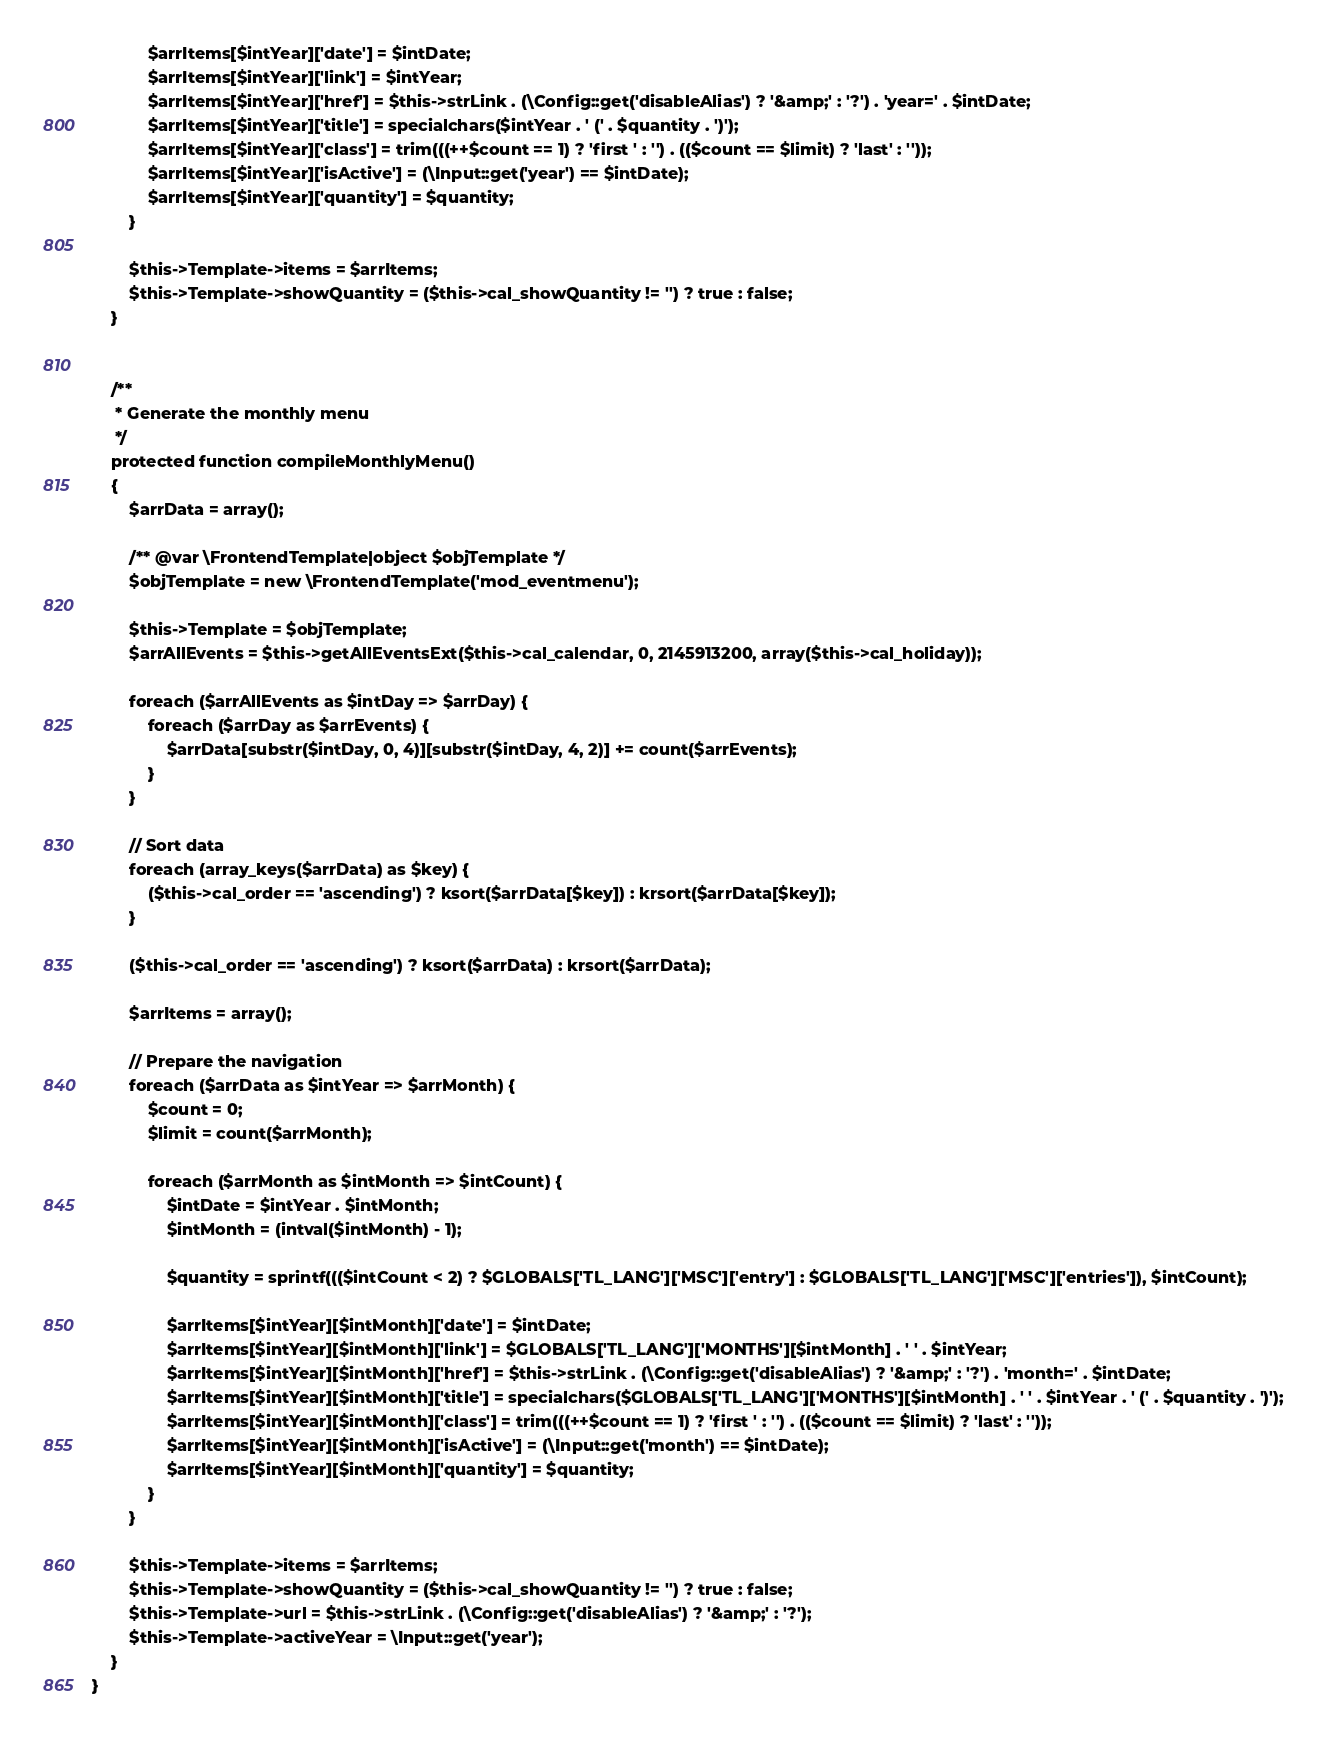<code> <loc_0><loc_0><loc_500><loc_500><_PHP_>
            $arrItems[$intYear]['date'] = $intDate;
            $arrItems[$intYear]['link'] = $intYear;
            $arrItems[$intYear]['href'] = $this->strLink . (\Config::get('disableAlias') ? '&amp;' : '?') . 'year=' . $intDate;
            $arrItems[$intYear]['title'] = specialchars($intYear . ' (' . $quantity . ')');
            $arrItems[$intYear]['class'] = trim(((++$count == 1) ? 'first ' : '') . (($count == $limit) ? 'last' : ''));
            $arrItems[$intYear]['isActive'] = (\Input::get('year') == $intDate);
            $arrItems[$intYear]['quantity'] = $quantity;
        }

        $this->Template->items = $arrItems;
        $this->Template->showQuantity = ($this->cal_showQuantity != '') ? true : false;
    }


    /**
     * Generate the monthly menu
     */
    protected function compileMonthlyMenu()
    {
        $arrData = array();

        /** @var \FrontendTemplate|object $objTemplate */
        $objTemplate = new \FrontendTemplate('mod_eventmenu');

        $this->Template = $objTemplate;
        $arrAllEvents = $this->getAllEventsExt($this->cal_calendar, 0, 2145913200, array($this->cal_holiday));

        foreach ($arrAllEvents as $intDay => $arrDay) {
            foreach ($arrDay as $arrEvents) {
                $arrData[substr($intDay, 0, 4)][substr($intDay, 4, 2)] += count($arrEvents);
            }
        }

        // Sort data
        foreach (array_keys($arrData) as $key) {
            ($this->cal_order == 'ascending') ? ksort($arrData[$key]) : krsort($arrData[$key]);
        }

        ($this->cal_order == 'ascending') ? ksort($arrData) : krsort($arrData);

        $arrItems = array();

        // Prepare the navigation
        foreach ($arrData as $intYear => $arrMonth) {
            $count = 0;
            $limit = count($arrMonth);

            foreach ($arrMonth as $intMonth => $intCount) {
                $intDate = $intYear . $intMonth;
                $intMonth = (intval($intMonth) - 1);

                $quantity = sprintf((($intCount < 2) ? $GLOBALS['TL_LANG']['MSC']['entry'] : $GLOBALS['TL_LANG']['MSC']['entries']), $intCount);

                $arrItems[$intYear][$intMonth]['date'] = $intDate;
                $arrItems[$intYear][$intMonth]['link'] = $GLOBALS['TL_LANG']['MONTHS'][$intMonth] . ' ' . $intYear;
                $arrItems[$intYear][$intMonth]['href'] = $this->strLink . (\Config::get('disableAlias') ? '&amp;' : '?') . 'month=' . $intDate;
                $arrItems[$intYear][$intMonth]['title'] = specialchars($GLOBALS['TL_LANG']['MONTHS'][$intMonth] . ' ' . $intYear . ' (' . $quantity . ')');
                $arrItems[$intYear][$intMonth]['class'] = trim(((++$count == 1) ? 'first ' : '') . (($count == $limit) ? 'last' : ''));
                $arrItems[$intYear][$intMonth]['isActive'] = (\Input::get('month') == $intDate);
                $arrItems[$intYear][$intMonth]['quantity'] = $quantity;
            }
        }

        $this->Template->items = $arrItems;
        $this->Template->showQuantity = ($this->cal_showQuantity != '') ? true : false;
        $this->Template->url = $this->strLink . (\Config::get('disableAlias') ? '&amp;' : '?');
        $this->Template->activeYear = \Input::get('year');
    }
}
</code> 